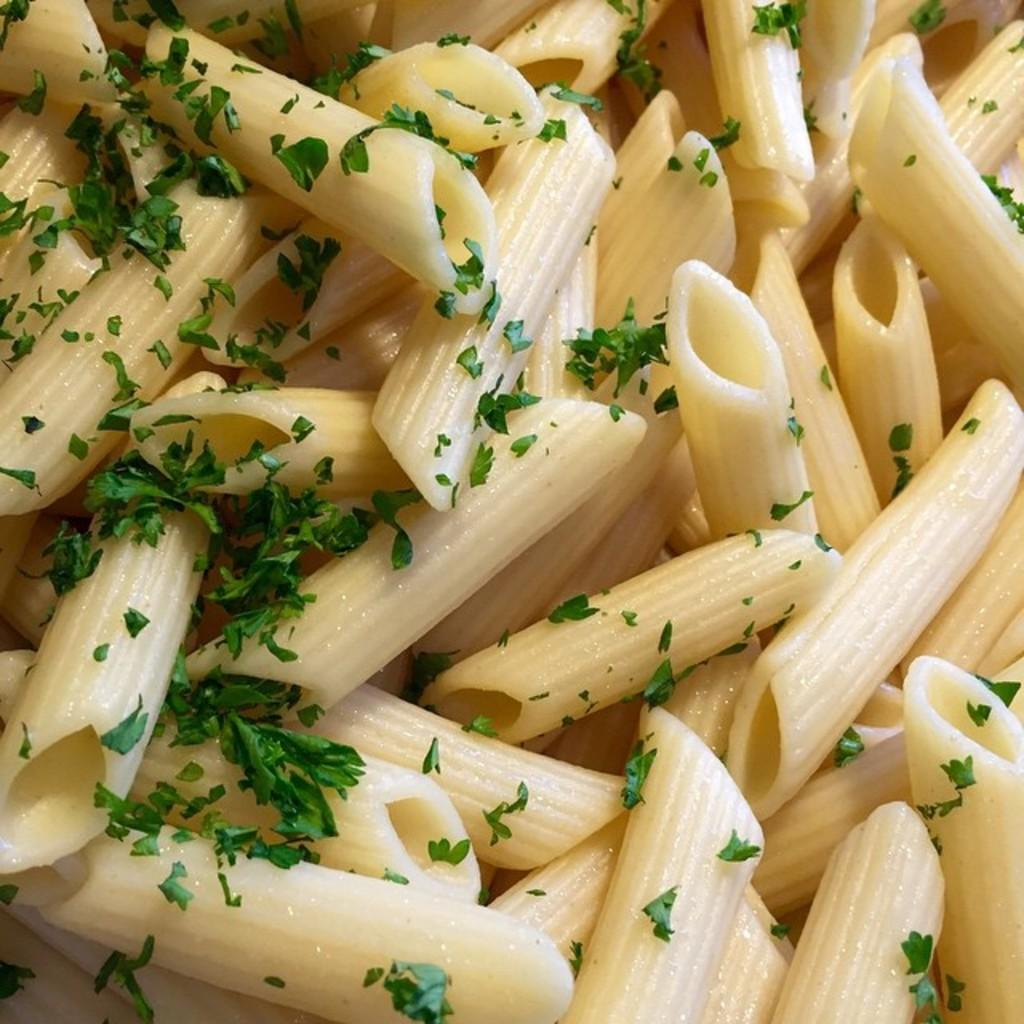What type of food is shown in the image? There is pasta in the image. What is sprinkled on top of the pasta? Coriander leaves are sprinkled on the pasta. What type of lock is used to secure the pasta in the image? There is no lock present in the image; it is a dish of pasta with coriander leaves sprinkled on top. 